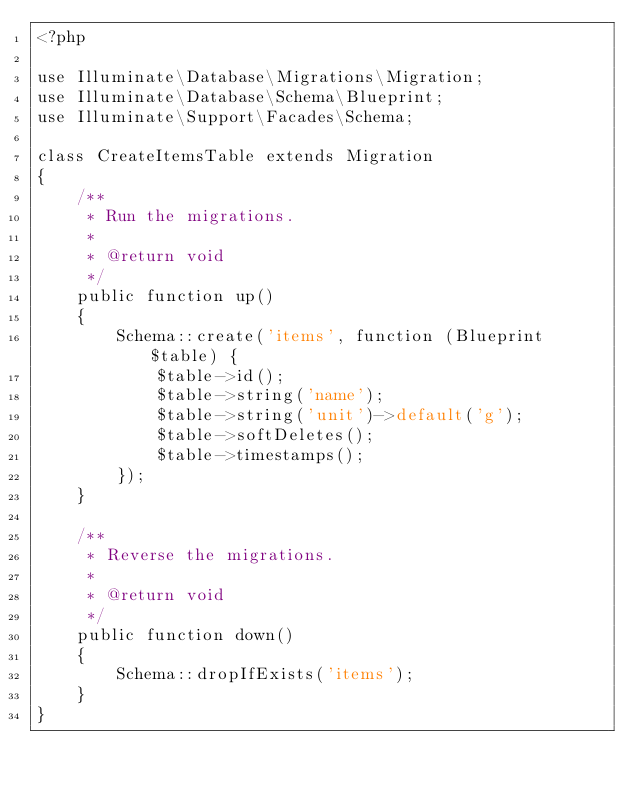Convert code to text. <code><loc_0><loc_0><loc_500><loc_500><_PHP_><?php

use Illuminate\Database\Migrations\Migration;
use Illuminate\Database\Schema\Blueprint;
use Illuminate\Support\Facades\Schema;

class CreateItemsTable extends Migration
{
    /**
     * Run the migrations.
     *
     * @return void
     */
    public function up()
    {
        Schema::create('items', function (Blueprint $table) {
            $table->id();
            $table->string('name');
            $table->string('unit')->default('g');
            $table->softDeletes();
            $table->timestamps();
        });
    }

    /**
     * Reverse the migrations.
     *
     * @return void
     */
    public function down()
    {
        Schema::dropIfExists('items');
    }
}
</code> 